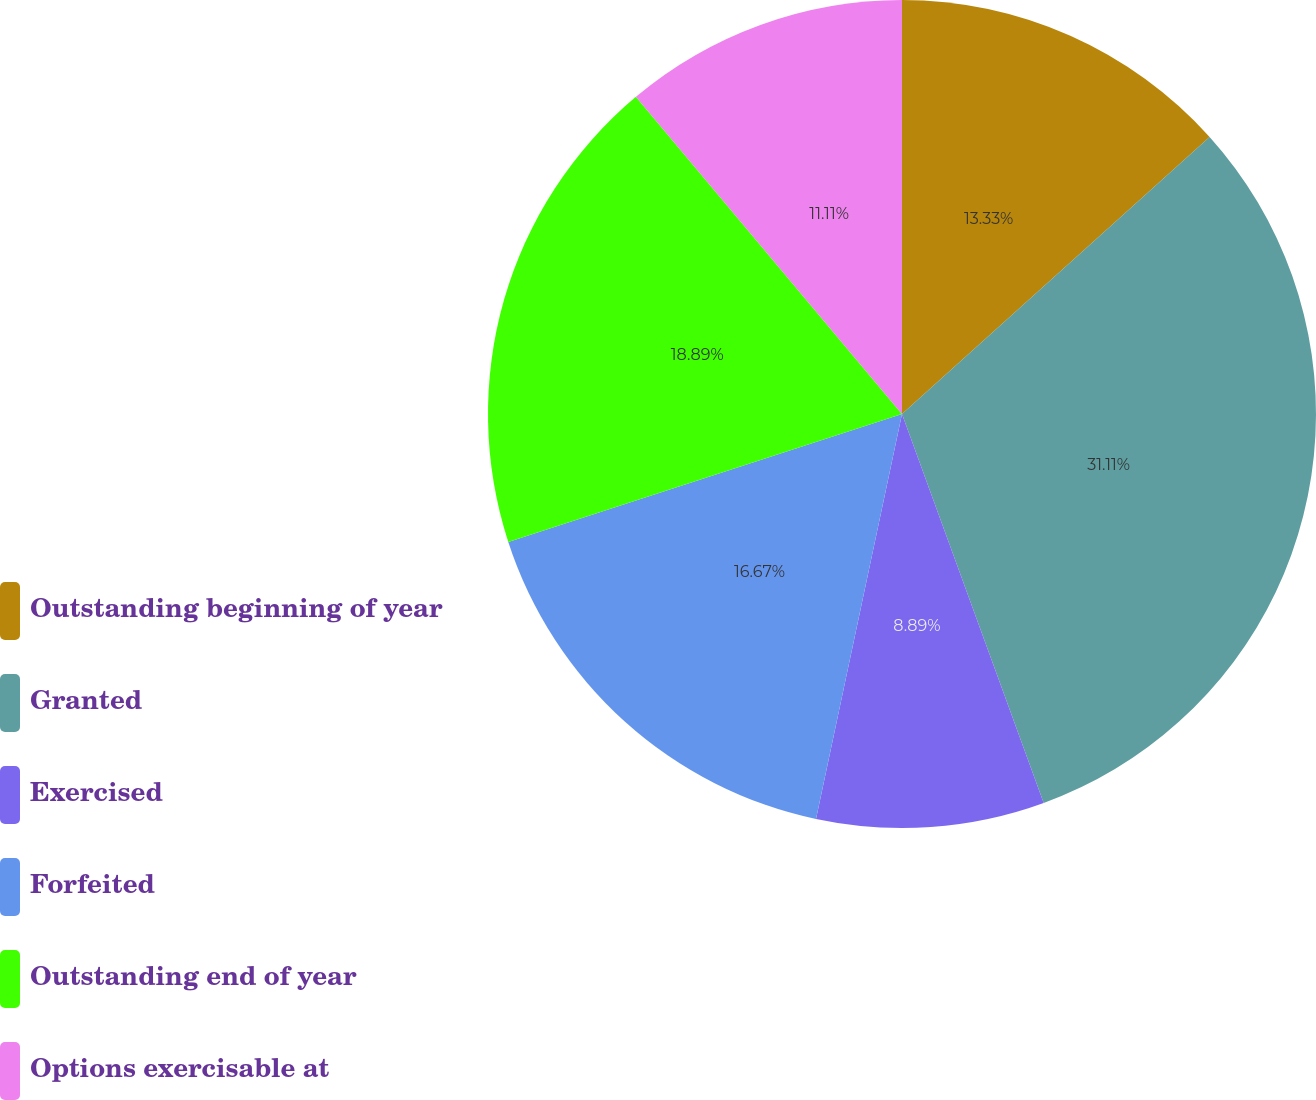Convert chart. <chart><loc_0><loc_0><loc_500><loc_500><pie_chart><fcel>Outstanding beginning of year<fcel>Granted<fcel>Exercised<fcel>Forfeited<fcel>Outstanding end of year<fcel>Options exercisable at<nl><fcel>13.33%<fcel>31.11%<fcel>8.89%<fcel>16.67%<fcel>18.89%<fcel>11.11%<nl></chart> 